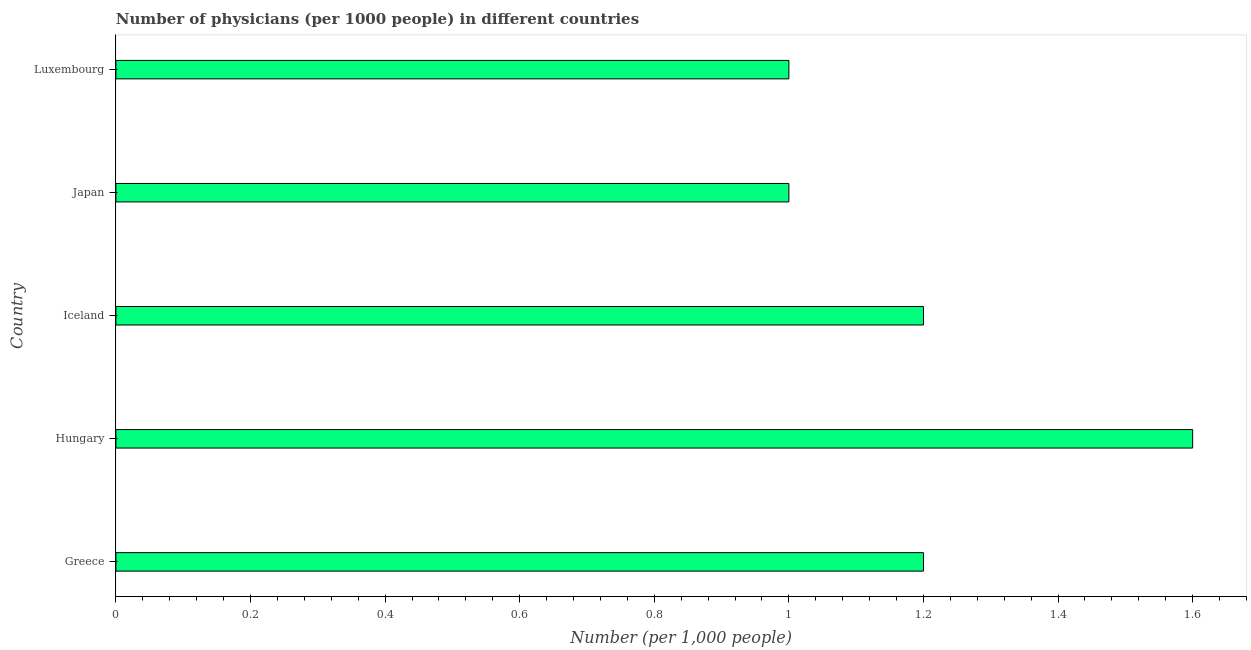What is the title of the graph?
Offer a terse response. Number of physicians (per 1000 people) in different countries. What is the label or title of the X-axis?
Keep it short and to the point. Number (per 1,0 people). What is the number of physicians in Luxembourg?
Your answer should be compact. 1. Across all countries, what is the minimum number of physicians?
Make the answer very short. 1. In which country was the number of physicians maximum?
Provide a succinct answer. Hungary. In which country was the number of physicians minimum?
Offer a very short reply. Japan. What is the sum of the number of physicians?
Ensure brevity in your answer.  6. What is the difference between the number of physicians in Greece and Hungary?
Keep it short and to the point. -0.4. What is the average number of physicians per country?
Provide a short and direct response. 1.2. What is the median number of physicians?
Your answer should be compact. 1.2. In how many countries, is the number of physicians greater than 0.24 ?
Provide a short and direct response. 5. Is the difference between the number of physicians in Hungary and Japan greater than the difference between any two countries?
Give a very brief answer. Yes. How many bars are there?
Provide a succinct answer. 5. Are all the bars in the graph horizontal?
Your response must be concise. Yes. How many countries are there in the graph?
Give a very brief answer. 5. What is the difference between two consecutive major ticks on the X-axis?
Keep it short and to the point. 0.2. Are the values on the major ticks of X-axis written in scientific E-notation?
Your answer should be very brief. No. What is the Number (per 1,000 people) in Hungary?
Provide a succinct answer. 1.6. What is the Number (per 1,000 people) in Iceland?
Keep it short and to the point. 1.2. What is the Number (per 1,000 people) in Japan?
Give a very brief answer. 1. What is the Number (per 1,000 people) in Luxembourg?
Give a very brief answer. 1. What is the difference between the Number (per 1,000 people) in Greece and Hungary?
Your answer should be compact. -0.4. What is the difference between the Number (per 1,000 people) in Hungary and Iceland?
Keep it short and to the point. 0.4. What is the difference between the Number (per 1,000 people) in Hungary and Japan?
Keep it short and to the point. 0.6. What is the difference between the Number (per 1,000 people) in Hungary and Luxembourg?
Keep it short and to the point. 0.6. What is the difference between the Number (per 1,000 people) in Iceland and Japan?
Keep it short and to the point. 0.2. What is the difference between the Number (per 1,000 people) in Japan and Luxembourg?
Keep it short and to the point. 0. What is the ratio of the Number (per 1,000 people) in Greece to that in Hungary?
Make the answer very short. 0.75. What is the ratio of the Number (per 1,000 people) in Greece to that in Luxembourg?
Offer a terse response. 1.2. What is the ratio of the Number (per 1,000 people) in Hungary to that in Iceland?
Offer a terse response. 1.33. 